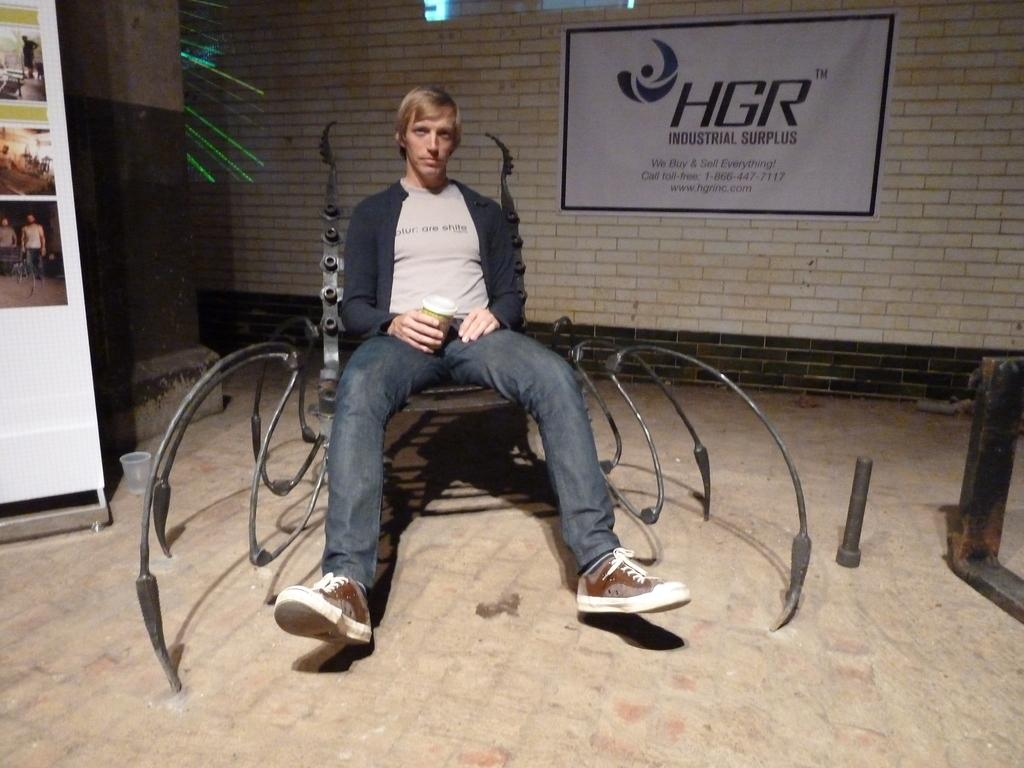Who is present in the image? There is a man in the image. What is the man doing in the image? The man is sitting on a chair. Where is the chair located in the image? The chair is on the floor. What can be seen behind the man in the image? There is a wall behind the man. How many ants are crawling on the man's arm in the image? There are no ants present in the image. What type of ink is the man using to make a decision in the image? There is no ink or decision-making activity depicted in the image. 